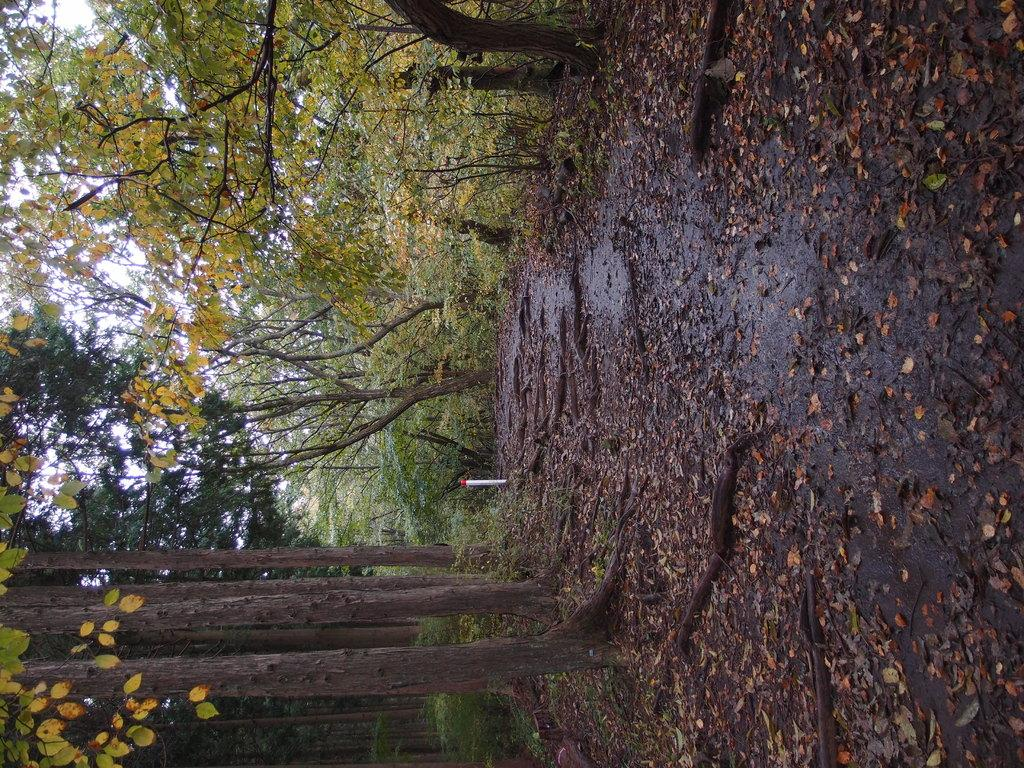What is on the ground in the image? There are dried leaves on the ground. What type of vegetation can be seen in the image? There are trees visible in the image. How many dimes can be seen on the trees in the image? There are no dimes present in the image; it features dried leaves on the ground and trees. What type of creature might be using the trees as a habitat in the image? The image does not show any creatures, so it is not possible to determine what type of creature might be using the trees as a habitat. 